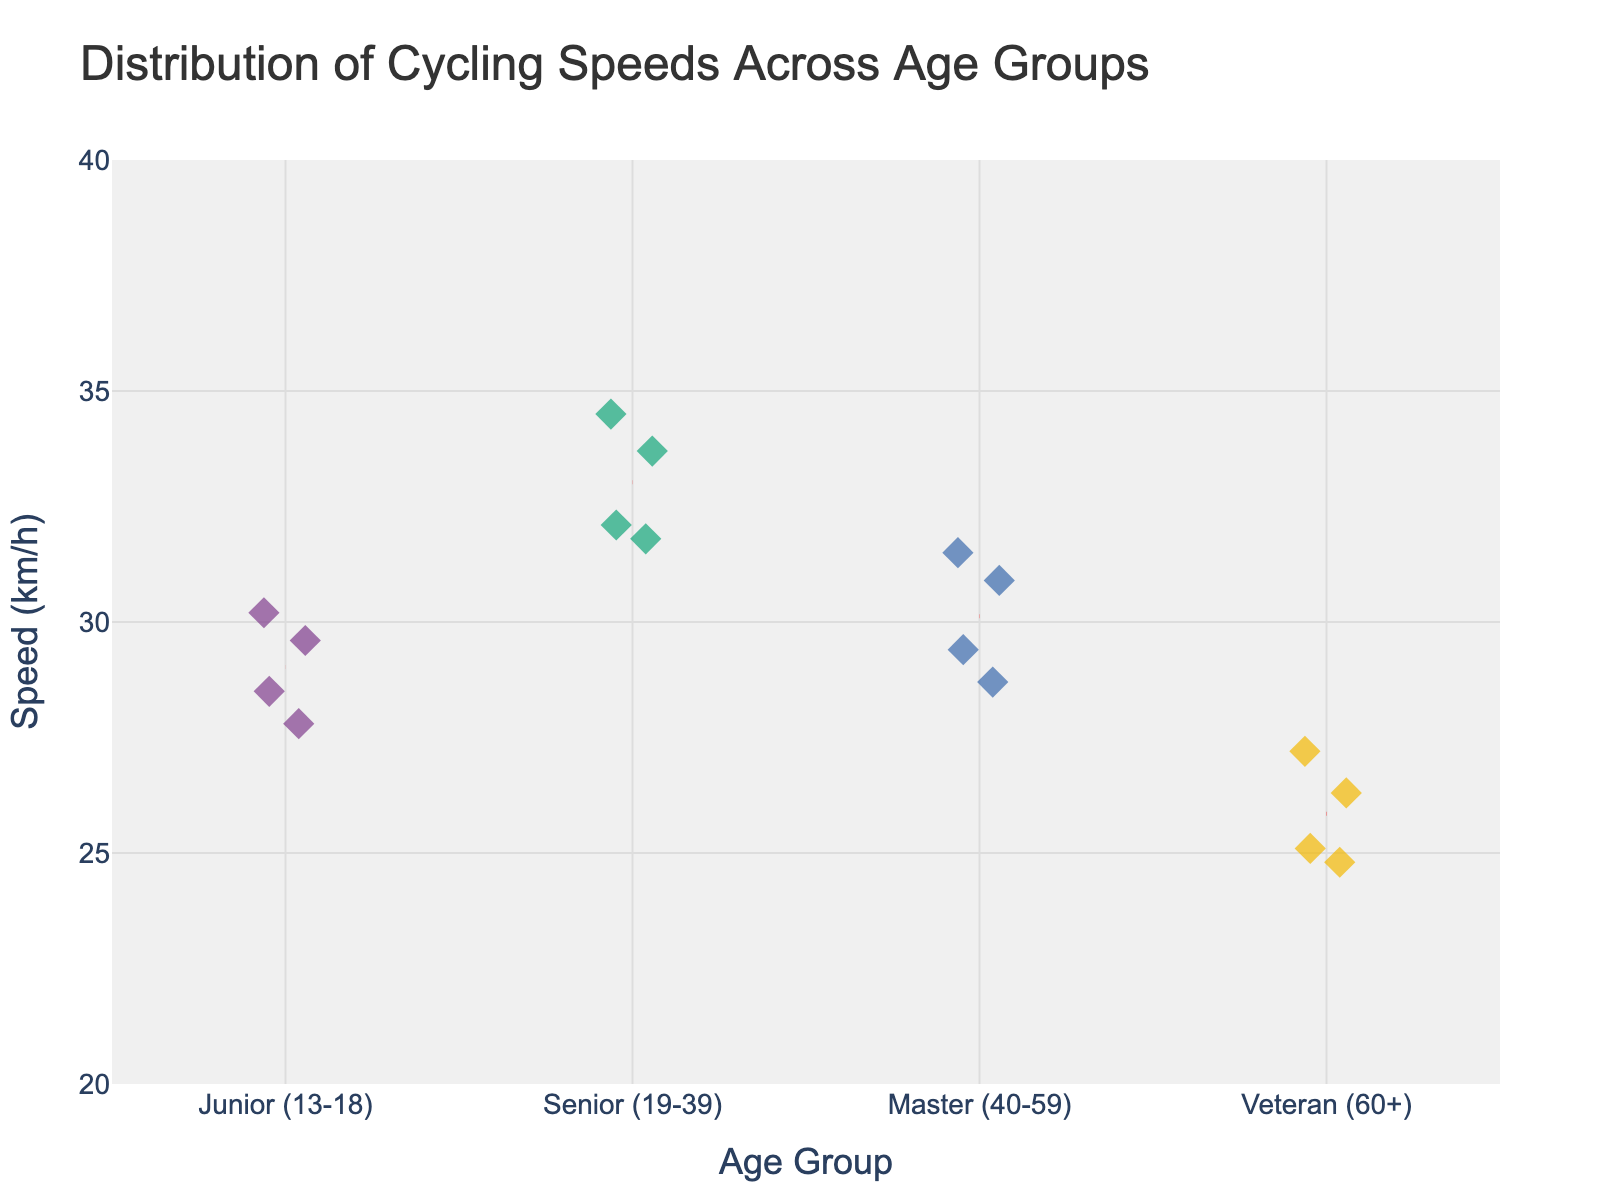What's the title of the plot? The title is typically displayed prominently at the top of the plot. It provides a brief description of the data being displayed.
Answer: Distribution of Cycling Speeds Across Age Groups What are the age groups represented in the plot? The age groups are displayed along the x-axis, which categorizes the data points. Each group name is clearly shown.
Answer: Junior (13-18), Senior (19-39), Master (40-59), Veteran (60+) Which age group has the highest mean cycling speed? Each age group has a dashed red line indicating the mean speed. By comparing the positions of these lines, we can identify the highest mean speed.
Answer: Senior (19-39) What is the range of speeds shown on the y-axis? The y-axis represents the speed in km/h, and its range is marked by the lowest and highest tick values.
Answer: 20 to 40 km/h How many data points are there for the Junior age group? Each data point within an age group is visually represented by a marker. Counting these markers tells us the number of data points.
Answer: 4 How does the mean speed of Veterans compare to Masters? The mean speed for each group is indicated by a red dashed line. By locating and comparing these lines for Veterans and Masters, we can assess their relative positions.
Answer: Veterans have a lower mean speed than Masters What is the approximate mean speed for the Senior age group? The mean speed for any age group can be found by looking at the height of the dashed red line for that group. The y-axis helps estimate this value.
Answer: Approximately 33 km/h Which age group shows the largest variation in cycling speeds? The spread of data points within an age group indicates its variation. Visually evaluating the spread helps to identify the group with the largest variation.
Answer: Senior (19-39) Is there any overlap in speed ranges between the Junior and Master age groups? By comparing the spread and positions of data points for Juniors and Masters along the y-axis, we can see if their ranges overlap.
Answer: Yes Which age group has the lowest individual cycling speed recorded? By identifying the lowest point on the y-axis and noting which age group it belongs to, we can determine the age group with the lowest speed.
Answer: Veteran (60+) 